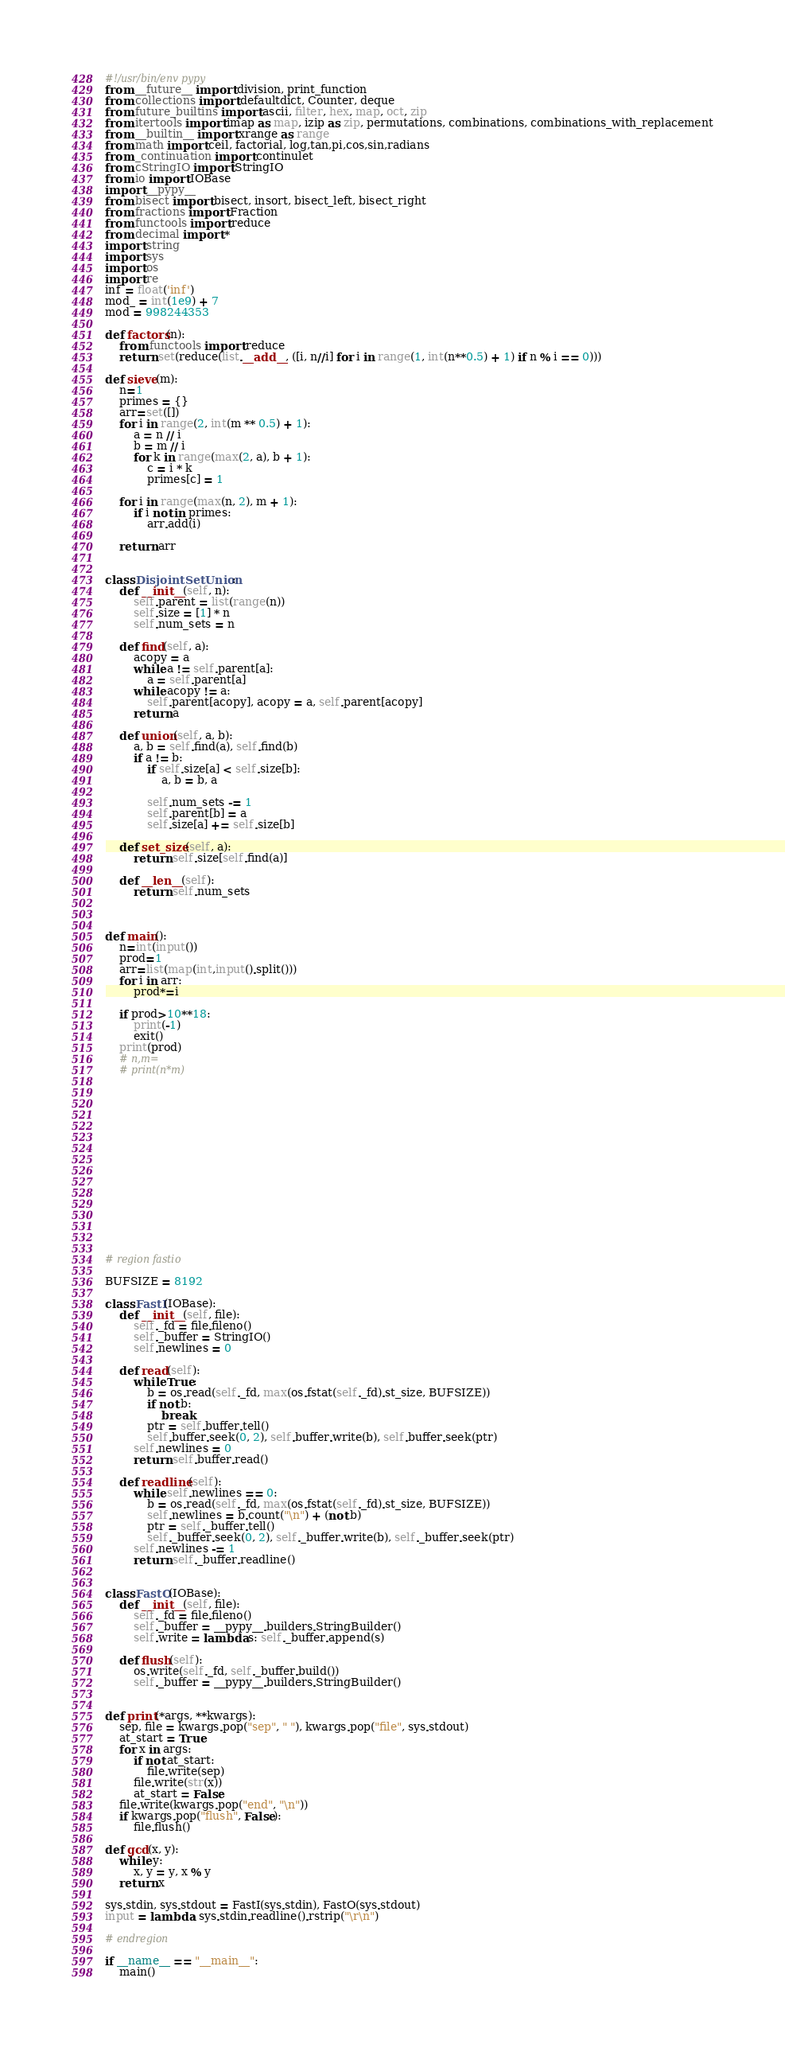Convert code to text. <code><loc_0><loc_0><loc_500><loc_500><_Python_>#!/usr/bin/env pypy
from __future__ import division, print_function
from collections import defaultdict, Counter, deque
from future_builtins import ascii, filter, hex, map, oct, zip
from itertools import imap as map, izip as zip, permutations, combinations, combinations_with_replacement
from __builtin__ import xrange as range
from math import ceil, factorial, log,tan,pi,cos,sin,radians
from _continuation import continulet
from cStringIO import StringIO
from io import IOBase
import __pypy__
from bisect import bisect, insort, bisect_left, bisect_right
from fractions import Fraction
from functools import reduce
from decimal import *
import string
import sys
import os
import re
inf = float('inf')
mod_ = int(1e9) + 7
mod = 998244353

def factors(n):
    from functools import reduce
    return set(reduce(list.__add__, ([i, n//i] for i in range(1, int(n**0.5) + 1) if n % i == 0)))

def sieve(m):
    n=1
    primes = {}
    arr=set([])
    for i in range(2, int(m ** 0.5) + 1):
        a = n // i
        b = m // i
        for k in range(max(2, a), b + 1):
            c = i * k
            primes[c] = 1

    for i in range(max(n, 2), m + 1):
        if i not in primes:
            arr.add(i)

    return arr


class DisjointSetUnion:
    def __init__(self, n):
        self.parent = list(range(n))
        self.size = [1] * n
        self.num_sets = n
 
    def find(self, a):
        acopy = a
        while a != self.parent[a]:
            a = self.parent[a]
        while acopy != a:
            self.parent[acopy], acopy = a, self.parent[acopy]
        return a
 
    def union(self, a, b):
        a, b = self.find(a), self.find(b)
        if a != b:
            if self.size[a] < self.size[b]:
                a, b = b, a
 
            self.num_sets -= 1
            self.parent[b] = a
            self.size[a] += self.size[b]
 
    def set_size(self, a):
        return self.size[self.find(a)]
 
    def __len__(self):
        return self.num_sets



def main():
    n=int(input())
    prod=1
    arr=list(map(int,input().split()))
    for i in arr:
        prod*=i

    if prod>10**18:
        print(-1)
        exit()
    print(prod)
    # n,m=
    # print(n*m)












    



# region fastio

BUFSIZE = 8192

class FastI(IOBase):
    def __init__(self, file):
        self._fd = file.fileno()
        self._buffer = StringIO()
        self.newlines = 0

    def read(self):
        while True:
            b = os.read(self._fd, max(os.fstat(self._fd).st_size, BUFSIZE))
            if not b:
                break
            ptr = self.buffer.tell()
            self.buffer.seek(0, 2), self.buffer.write(b), self.buffer.seek(ptr)
        self.newlines = 0
        return self.buffer.read()

    def readline(self):
        while self.newlines == 0:
            b = os.read(self._fd, max(os.fstat(self._fd).st_size, BUFSIZE))
            self.newlines = b.count("\n") + (not b)
            ptr = self._buffer.tell()
            self._buffer.seek(0, 2), self._buffer.write(b), self._buffer.seek(ptr)
        self.newlines -= 1
        return self._buffer.readline()


class FastO(IOBase):
    def __init__(self, file):
        self._fd = file.fileno()
        self._buffer = __pypy__.builders.StringBuilder()
        self.write = lambda s: self._buffer.append(s)

    def flush(self):
        os.write(self._fd, self._buffer.build())
        self._buffer = __pypy__.builders.StringBuilder()


def print(*args, **kwargs):
    sep, file = kwargs.pop("sep", " "), kwargs.pop("file", sys.stdout)
    at_start = True
    for x in args:
        if not at_start:
            file.write(sep)
        file.write(str(x))
        at_start = False
    file.write(kwargs.pop("end", "\n"))
    if kwargs.pop("flush", False):
        file.flush()

def gcd(x, y):
    while y:
        x, y = y, x % y
    return x

sys.stdin, sys.stdout = FastI(sys.stdin), FastO(sys.stdout)
input = lambda: sys.stdin.readline().rstrip("\r\n")

# endregion

if __name__ == "__main__":
    main()</code> 